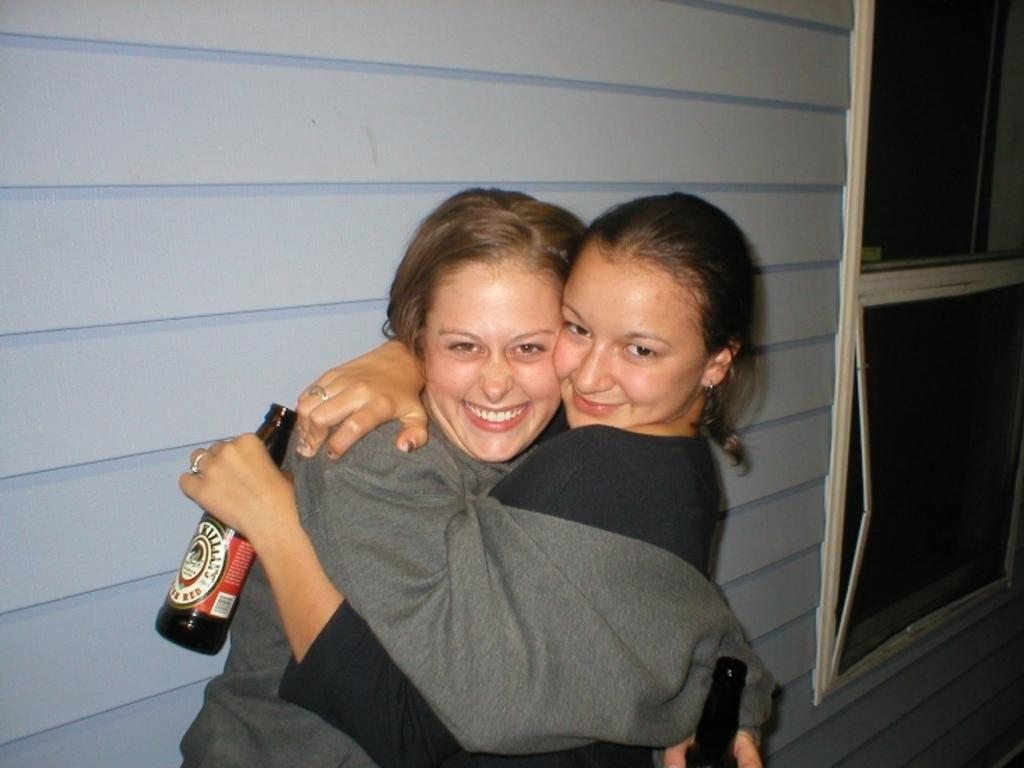How many people are in the image? There are two women in the image. What are the women doing in the image? The women are hugging each other. What expression do the women have on their faces? There is a smile on their faces. What is one of the women holding in the image? One of the women is holding a bottle. What type of produce can be seen growing in the cellar in the image? There is no cellar or produce present in the image. How does the wind blow the women's hair in the image? There is no wind blowing in the image, and the women's hair is not mentioned. 